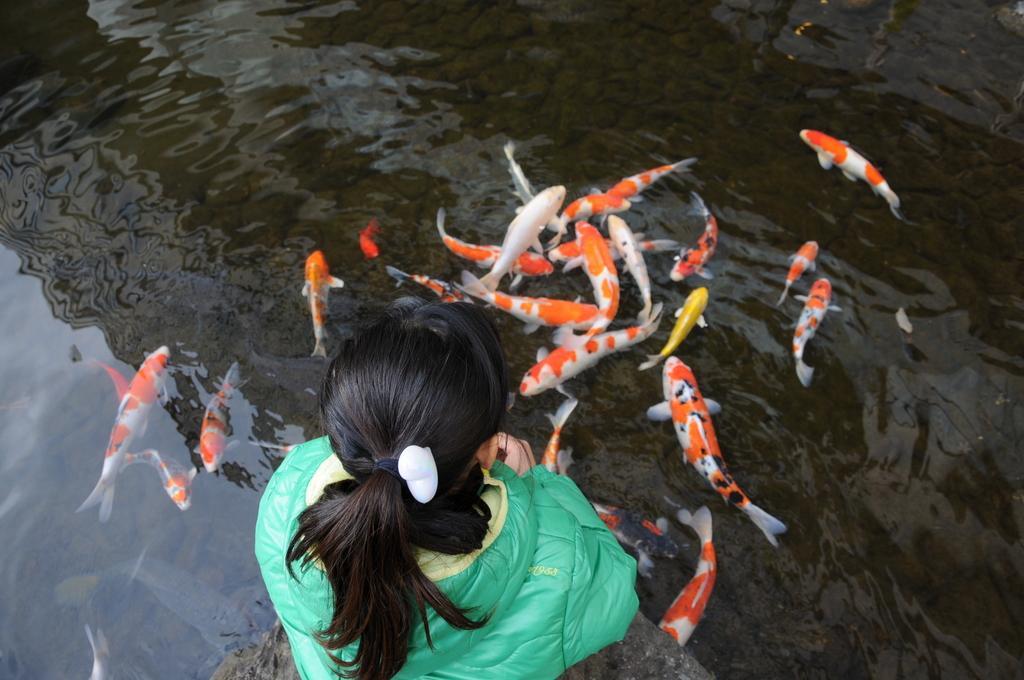Describe this image in one or two sentences. In this picture I can see a woman sitting on the rock in front of the water, some fishes are in the water. 